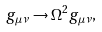<formula> <loc_0><loc_0><loc_500><loc_500>g _ { \mu \nu } \rightarrow \Omega ^ { 2 } g _ { \mu \nu } ,</formula> 